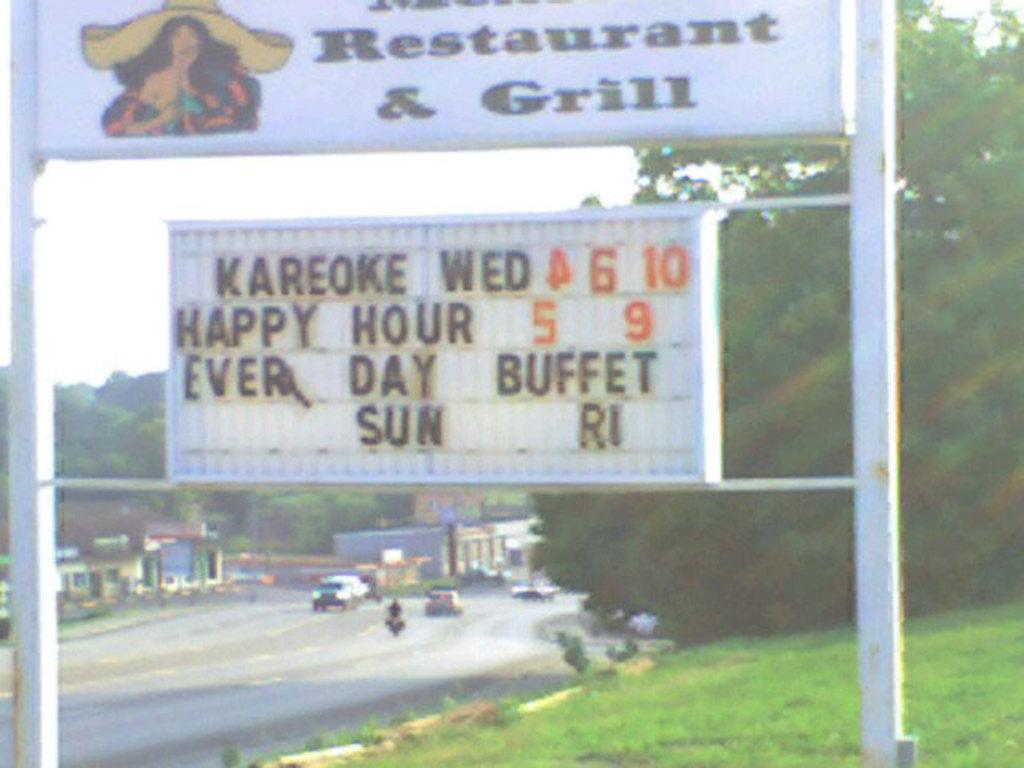What is happy hour?
Make the answer very short. 5-9. Do they grill here?
Ensure brevity in your answer.  Yes. 